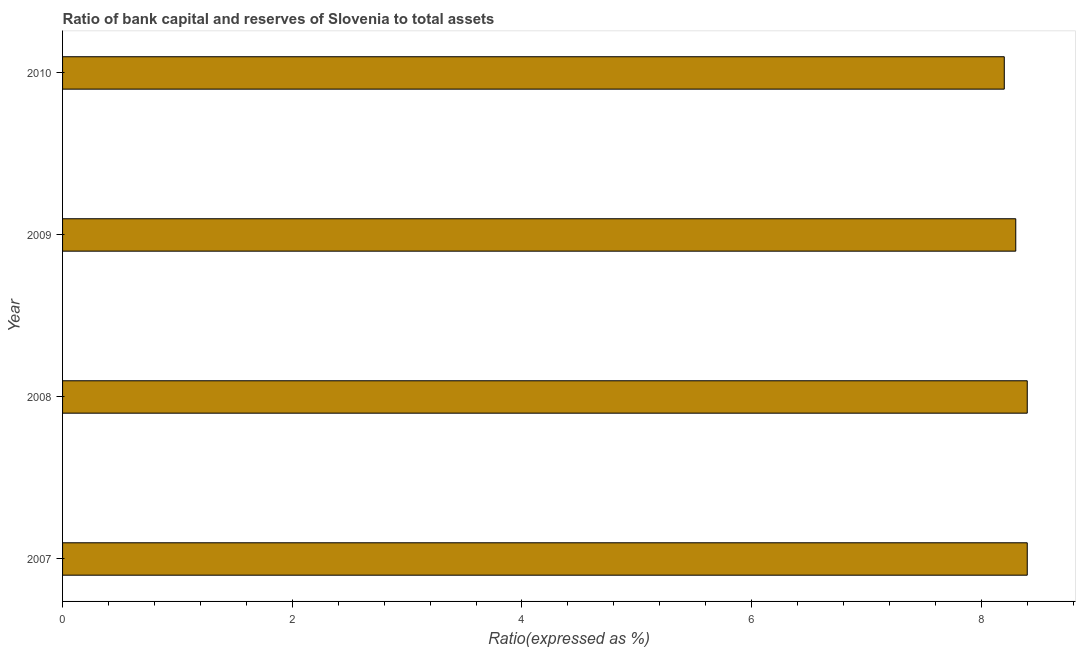Does the graph contain any zero values?
Give a very brief answer. No. Does the graph contain grids?
Make the answer very short. No. What is the title of the graph?
Ensure brevity in your answer.  Ratio of bank capital and reserves of Slovenia to total assets. What is the label or title of the X-axis?
Make the answer very short. Ratio(expressed as %). What is the bank capital to assets ratio in 2009?
Your answer should be compact. 8.3. Across all years, what is the minimum bank capital to assets ratio?
Your answer should be very brief. 8.2. What is the sum of the bank capital to assets ratio?
Your answer should be compact. 33.3. What is the average bank capital to assets ratio per year?
Keep it short and to the point. 8.32. What is the median bank capital to assets ratio?
Ensure brevity in your answer.  8.35. Do a majority of the years between 2010 and 2007 (inclusive) have bank capital to assets ratio greater than 7.6 %?
Make the answer very short. Yes. What is the ratio of the bank capital to assets ratio in 2008 to that in 2009?
Your answer should be very brief. 1.01. Is the bank capital to assets ratio in 2007 less than that in 2010?
Offer a terse response. No. Is the difference between the bank capital to assets ratio in 2007 and 2010 greater than the difference between any two years?
Your response must be concise. Yes. Is the sum of the bank capital to assets ratio in 2007 and 2010 greater than the maximum bank capital to assets ratio across all years?
Your response must be concise. Yes. In how many years, is the bank capital to assets ratio greater than the average bank capital to assets ratio taken over all years?
Offer a terse response. 2. Are all the bars in the graph horizontal?
Keep it short and to the point. Yes. How many years are there in the graph?
Your answer should be compact. 4. What is the difference between two consecutive major ticks on the X-axis?
Give a very brief answer. 2. What is the Ratio(expressed as %) in 2009?
Provide a succinct answer. 8.3. What is the difference between the Ratio(expressed as %) in 2007 and 2008?
Make the answer very short. 0. What is the difference between the Ratio(expressed as %) in 2007 and 2010?
Ensure brevity in your answer.  0.2. What is the difference between the Ratio(expressed as %) in 2008 and 2010?
Your response must be concise. 0.2. What is the ratio of the Ratio(expressed as %) in 2007 to that in 2010?
Offer a very short reply. 1.02. What is the ratio of the Ratio(expressed as %) in 2008 to that in 2010?
Provide a succinct answer. 1.02. What is the ratio of the Ratio(expressed as %) in 2009 to that in 2010?
Offer a very short reply. 1.01. 